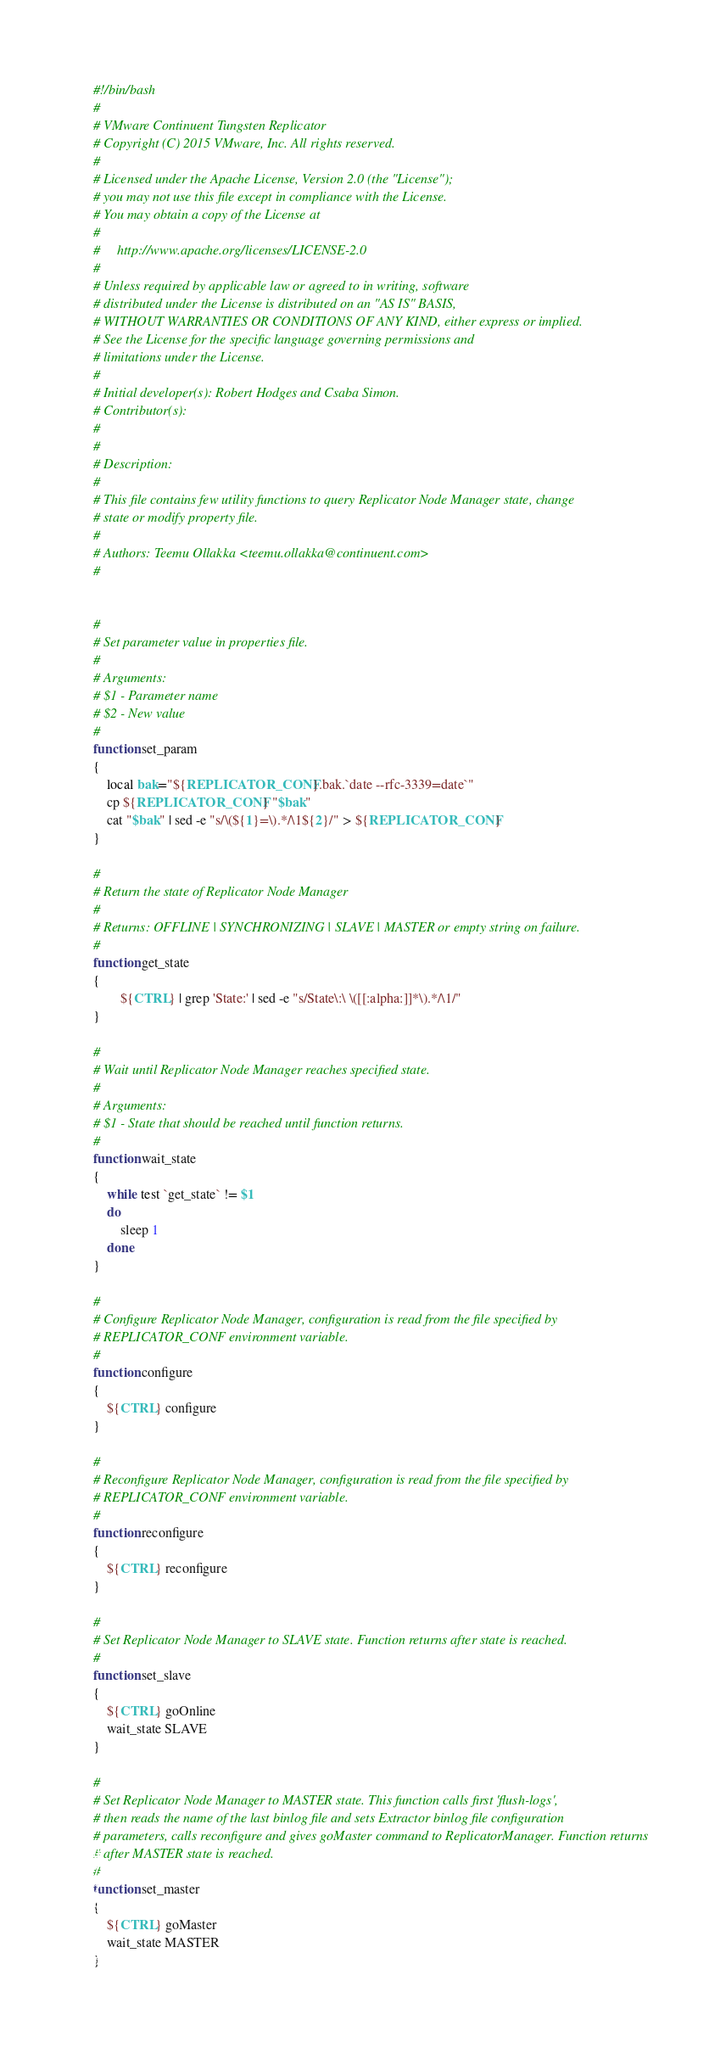Convert code to text. <code><loc_0><loc_0><loc_500><loc_500><_Bash_>#!/bin/bash
#
# VMware Continuent Tungsten Replicator
# Copyright (C) 2015 VMware, Inc. All rights reserved.
#
# Licensed under the Apache License, Version 2.0 (the "License");
# you may not use this file except in compliance with the License.
# You may obtain a copy of the License at
#
#     http://www.apache.org/licenses/LICENSE-2.0
#
# Unless required by applicable law or agreed to in writing, software
# distributed under the License is distributed on an "AS IS" BASIS,
# WITHOUT WARRANTIES OR CONDITIONS OF ANY KIND, either express or implied.
# See the License for the specific language governing permissions and
# limitations under the License.
#
# Initial developer(s): Robert Hodges and Csaba Simon.
# Contributor(s):
#
#
# Description:
#
# This file contains few utility functions to query Replicator Node Manager state, change
# state or modify property file.
#
# Authors: Teemu Ollakka <teemu.ollakka@continuent.com>
#


#
# Set parameter value in properties file. 
#
# Arguments:
# $1 - Parameter name
# $2 - New value
#
function set_param
{
	local bak="${REPLICATOR_CONF}.bak.`date --rfc-3339=date`"
	cp ${REPLICATOR_CONF} "$bak"
	cat "$bak" | sed -e "s/\(${1}=\).*/\1${2}/" > ${REPLICATOR_CONF}
}

#
# Return the state of Replicator Node Manager 
#
# Returns: OFFLINE | SYNCHRONIZING | SLAVE | MASTER or empty string on failure.
#
function get_state
{
        ${CTRL} | grep 'State:' | sed -e "s/State\:\ \([[:alpha:]]*\).*/\1/"
}

#
# Wait until Replicator Node Manager reaches specified state.
#
# Arguments:
# $1 - State that should be reached until function returns.
#
function wait_state
{
	while test `get_state` != $1
	do
		sleep 1
	done
}

#
# Configure Replicator Node Manager, configuration is read from the file specified by 
# REPLICATOR_CONF environment variable.
#
function configure
{
	${CTRL} configure
}

#
# Reconfigure Replicator Node Manager, configuration is read from the file specified by
# REPLICATOR_CONF environment variable.
#
function reconfigure
{
	${CTRL} reconfigure
}

#
# Set Replicator Node Manager to SLAVE state. Function returns after state is reached.
#
function set_slave
{
	${CTRL} goOnline
	wait_state SLAVE
}

#
# Set Replicator Node Manager to MASTER state. This function calls first 'flush-logs', 
# then reads the name of the last binlog file and sets Extractor binlog file configuration
# parameters, calls reconfigure and gives goMaster command to ReplicatorManager. Function returns 
# after MASTER state is reached.
#
function set_master
{
	${CTRL} goMaster
	wait_state MASTER
}

</code> 